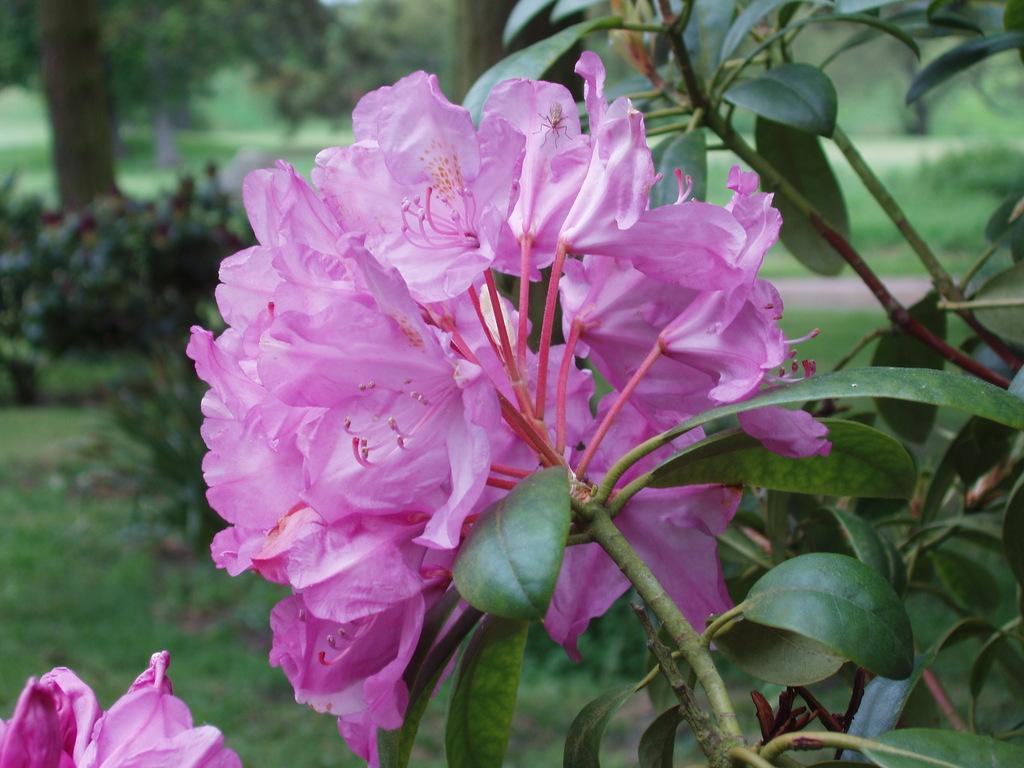Please provide a concise description of this image. There are pink color flowers on a plant. In the background there are trees, plants and grass on the ground. And it is blurred in the background. 